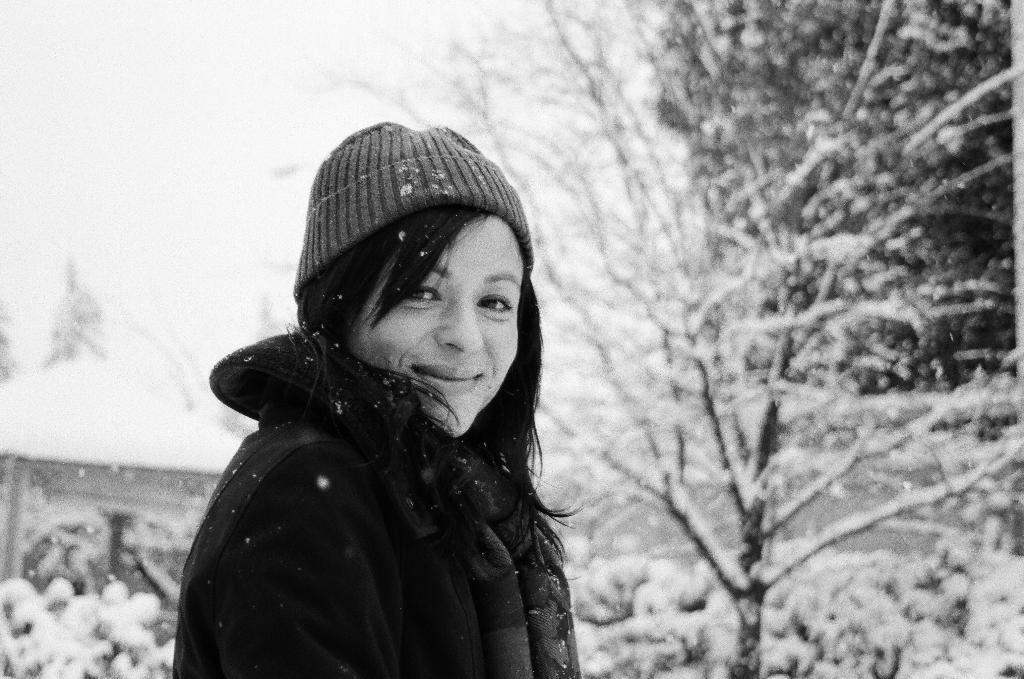What is the color scheme of the image? The image is black and white. Can you describe the person in the image? The person is wearing a woolen cap and a jacket. What can be seen in the background of the image? There are trees in the background of the image. How are the trees in the background of the image? The trees are covered with snow. What type of plate is being used to catch the snow falling from the person's nose in the image? There is no plate or snow falling from the person's nose in the image. What is the tin used for in the image? There is no tin present in the image. 